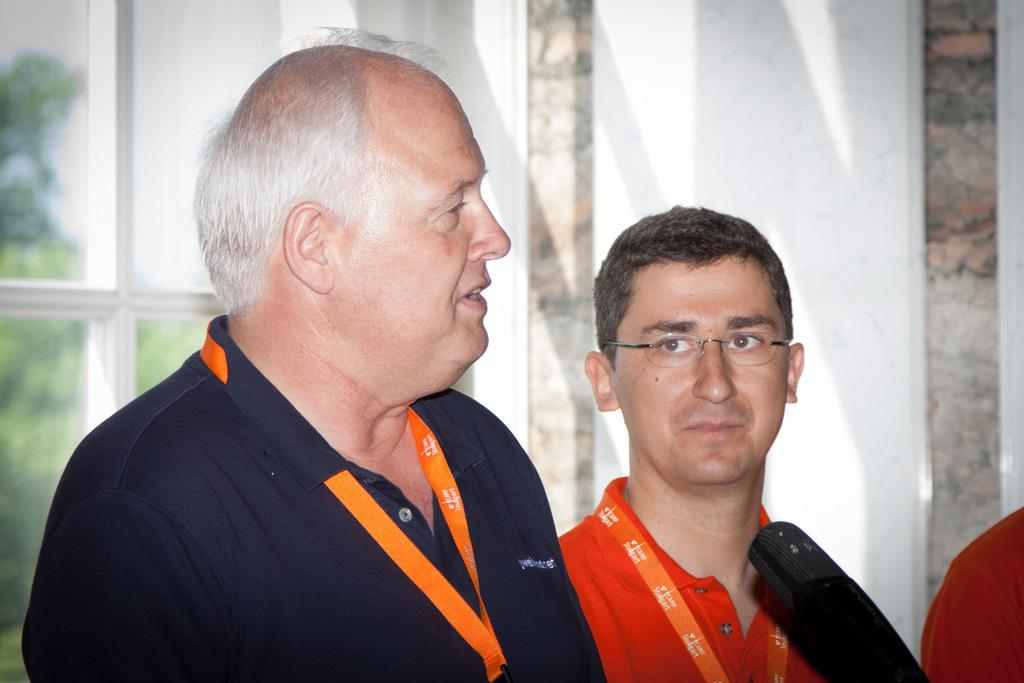How many people are in the image? There are two persons in the image. What are the people wearing that is noticeable? Both persons are wearing orange color tags. Can you describe the appearance of one of the persons? The person on the right is wearing specs. What object is placed in front of the two persons? There is a mic in front of the two persons. What can be seen in the background of the image? There is a wall and a glass window in the background of the image. What type of lead is being used by the person on the left in the image? There is no lead present in the image, and the person on the left is not holding or using any lead. Can you hear the sound of a horn in the image? There is no horn present in the image, and no sound can be heard from the image. 